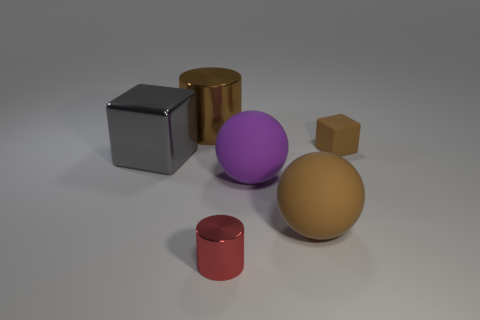Add 1 small red metal cylinders. How many objects exist? 7 Subtract all cubes. How many objects are left? 4 Subtract all small brown shiny objects. Subtract all big blocks. How many objects are left? 5 Add 4 gray metal blocks. How many gray metal blocks are left? 5 Add 4 tiny metal cylinders. How many tiny metal cylinders exist? 5 Subtract 0 purple cylinders. How many objects are left? 6 